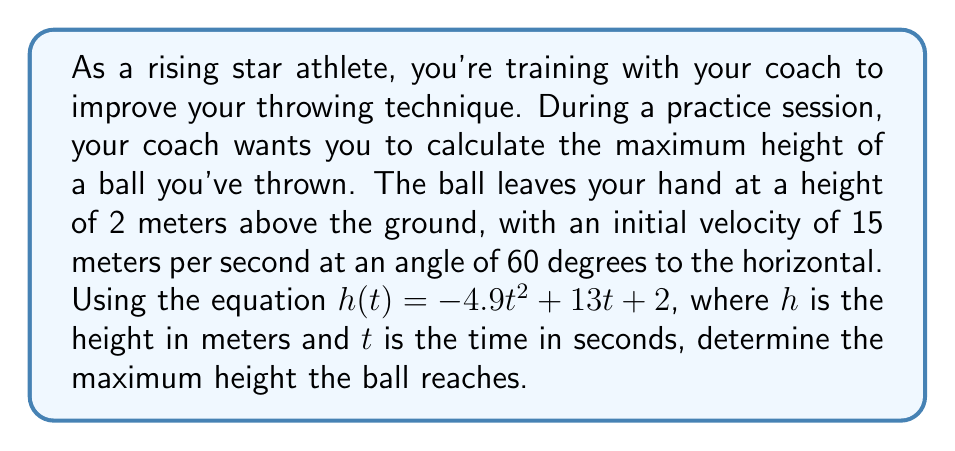Provide a solution to this math problem. Let's approach this step-by-step:

1) The equation given is in the form of a quadratic function:
   $h(t) = -4.9t^2 + 13t + 2$

2) To find the maximum height, we need to find the vertex of this parabola. The vertex represents the highest point of the trajectory.

3) For a quadratic function in the form $f(x) = ax^2 + bx + c$, the x-coordinate of the vertex is given by $x = -\frac{b}{2a}$

4) In our case, $a = -4.9$, $b = 13$, and $c = 2$

5) Let's calculate the time $t$ at which the ball reaches its maximum height:

   $t = -\frac{b}{2a} = -\frac{13}{2(-4.9)} = \frac{13}{9.8} \approx 1.33$ seconds

6) Now that we know the time, we can substitute this back into our original equation to find the maximum height:

   $h(1.33) = -4.9(1.33)^2 + 13(1.33) + 2$
   
   $= -4.9(1.77) + 17.29 + 2$
   
   $= -8.67 + 17.29 + 2$
   
   $= 10.62$ meters

Therefore, the maximum height the ball reaches is approximately 10.62 meters.
Answer: The maximum height the ball reaches is approximately 10.62 meters. 